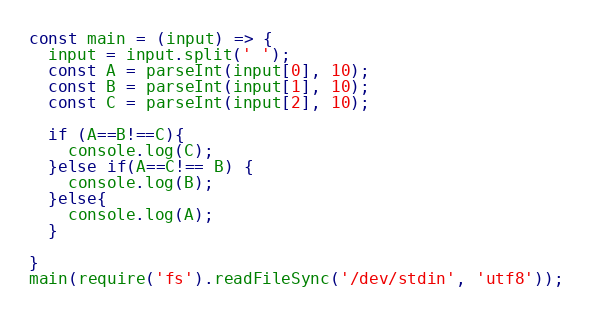Convert code to text. <code><loc_0><loc_0><loc_500><loc_500><_TypeScript_>const main = (input) => {
  input = input.split(' ');
  const A = parseInt(input[0], 10);
  const B = parseInt(input[1], 10);
  const C = parseInt(input[2], 10);
  
  if (A==B!==C){
    console.log(C);
  }else if(A==C!== B) {
    console.log(B);
  }else{
    console.log(A);
  }
  
}
main(require('fs').readFileSync('/dev/stdin', 'utf8'));</code> 